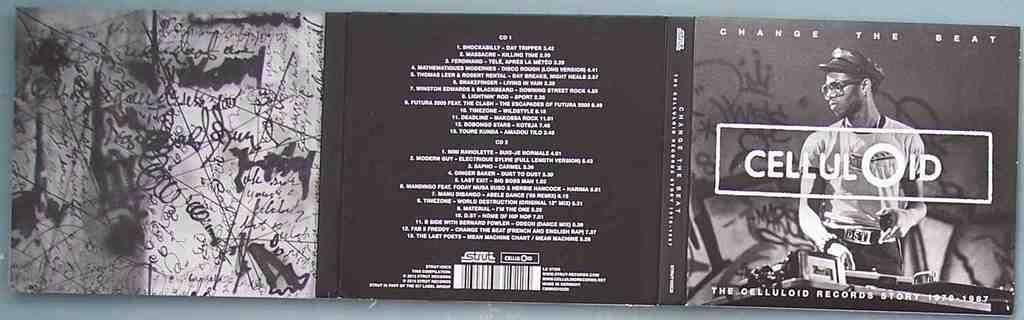<image>
Give a short and clear explanation of the subsequent image. The CD sleeve for the Change the Beat album by Celluloid Records. 